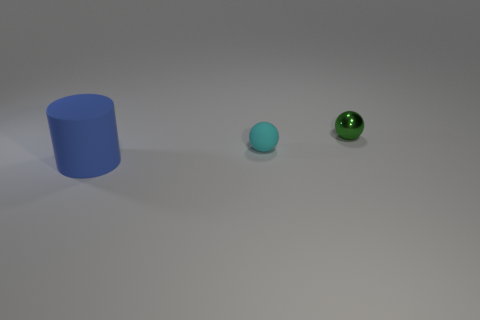Add 1 big yellow cylinders. How many objects exist? 4 Subtract all balls. How many objects are left? 1 Add 3 tiny objects. How many tiny objects are left? 5 Add 3 large cylinders. How many large cylinders exist? 4 Subtract 0 gray spheres. How many objects are left? 3 Subtract all big matte things. Subtract all blue matte cylinders. How many objects are left? 1 